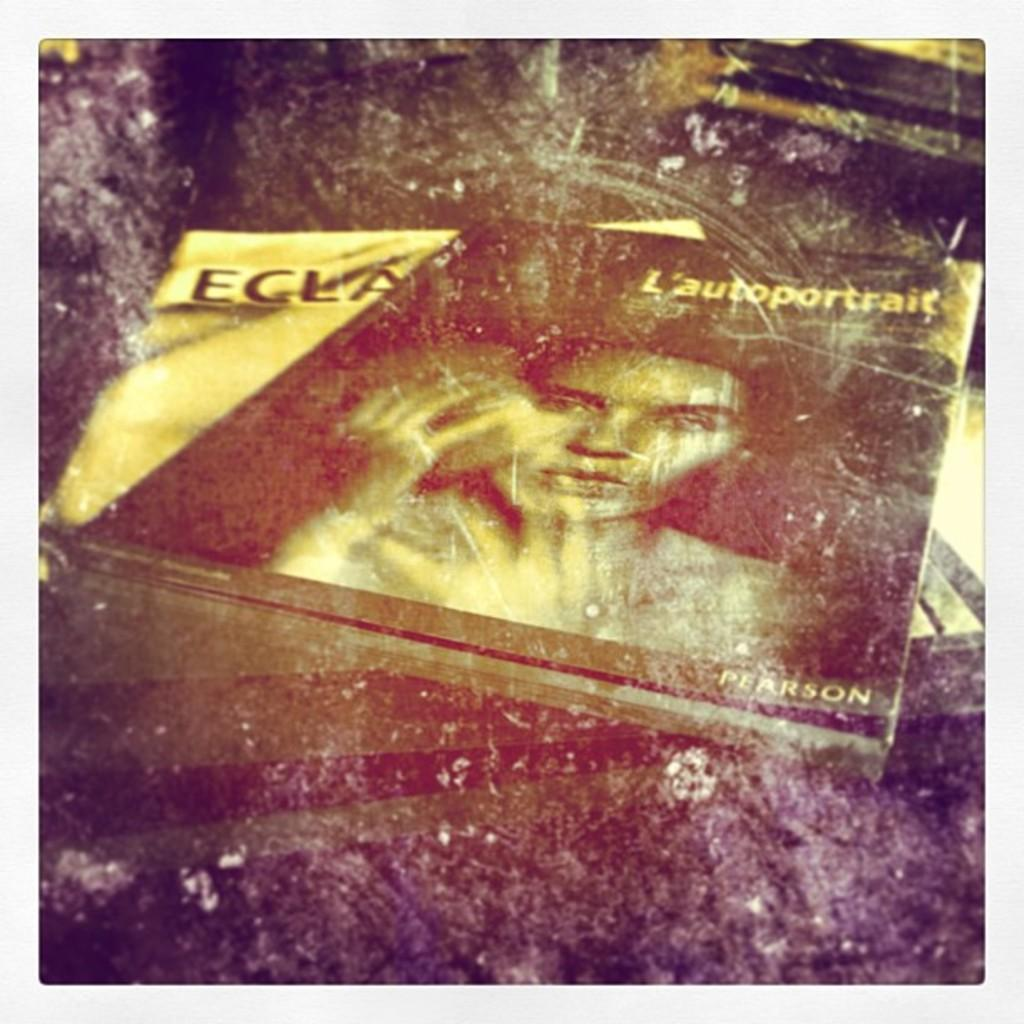What type of book is visible in the image? There is a Pearson book in the image. What is the color of the other book in the image? There is a yellow color book in the image. Where are the books located in the image? Both books are on a table. How many legs are visible on the books in the image? Books do not have legs, so none are visible in the image. What type of feast is being prepared on the table in the image? There is no feast or any indication of food preparation in the image; it only features two books on a table. 